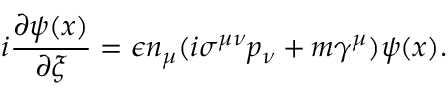Convert formula to latex. <formula><loc_0><loc_0><loc_500><loc_500>i \frac { \partial \psi ( x ) } { \partial \xi } = \epsilon n _ { \mu } ( i \sigma ^ { \mu \nu } p _ { \nu } + m \gamma ^ { \mu } ) \psi ( x ) .</formula> 